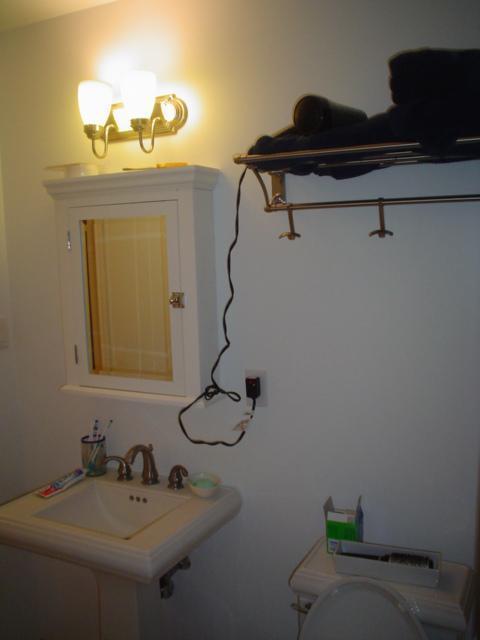How many lights are on the bathroom wall?
Give a very brief answer. 2. How many tubes of toothpaste are on the sink?
Give a very brief answer. 1. How many plugins are being used?
Give a very brief answer. 1. How many lights are pictured?
Give a very brief answer. 2. How many people are in the picture?
Give a very brief answer. 0. 